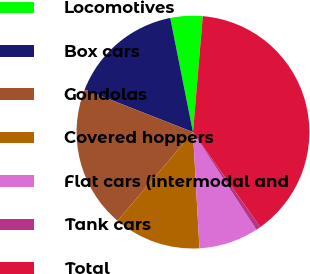<chart> <loc_0><loc_0><loc_500><loc_500><pie_chart><fcel>Locomotives<fcel>Box cars<fcel>Gondolas<fcel>Covered hoppers<fcel>Flat cars (intermodal and<fcel>Tank cars<fcel>Total<nl><fcel>4.47%<fcel>15.92%<fcel>19.74%<fcel>12.1%<fcel>8.29%<fcel>0.65%<fcel>38.83%<nl></chart> 